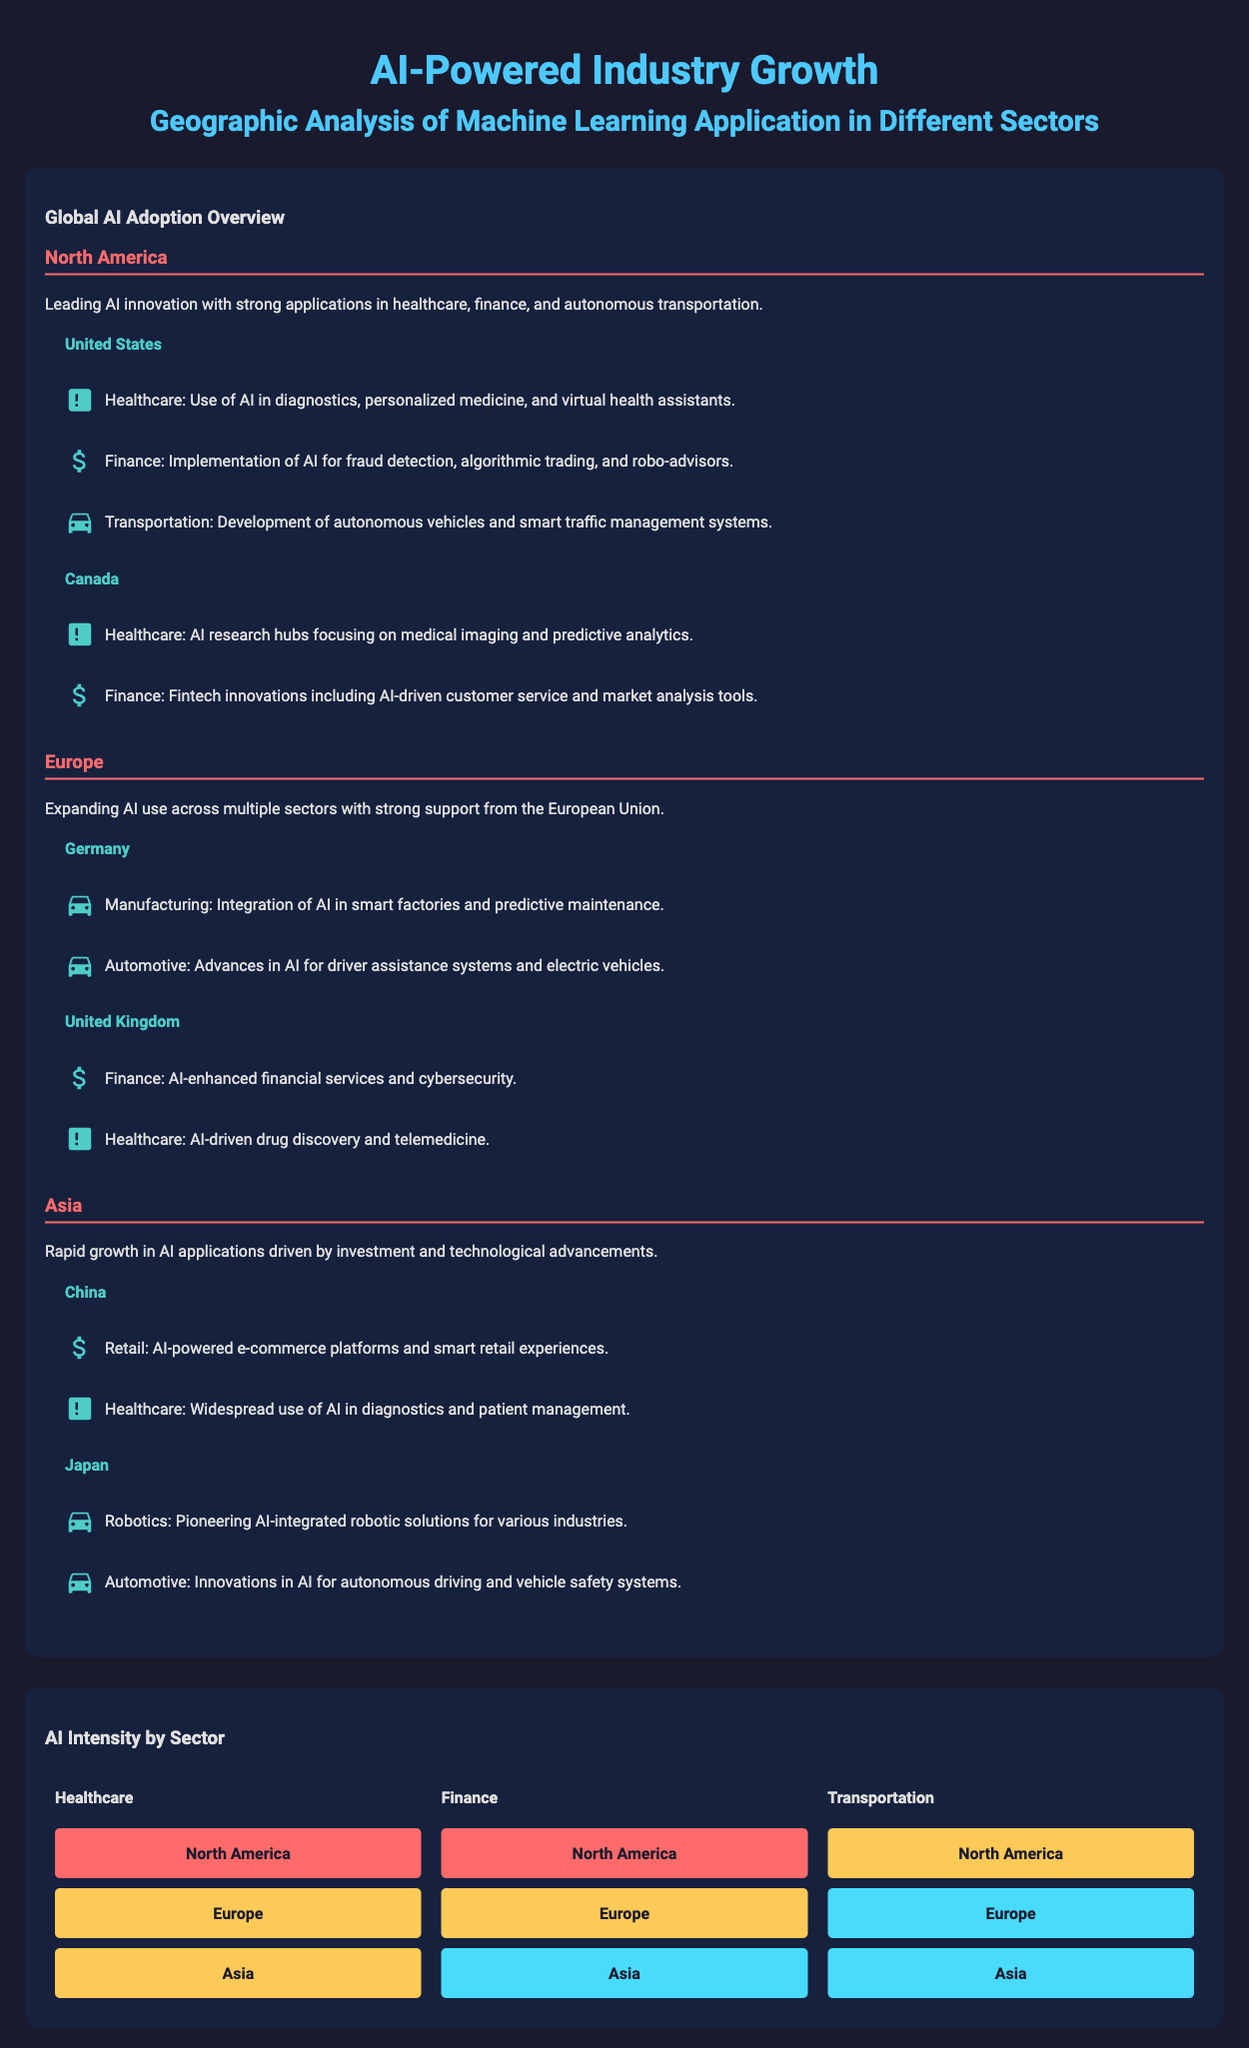What region is leading in AI innovation? North America is described as the leading region for AI innovation within the document.
Answer: North America Which country is mentioned first in the healthcare sector under North America? The document lists the United States first regarding healthcare applications of AI.
Answer: United States How many sectors are listed under the United Kingdom? The United Kingdom has two sectors mentioned in the document: finance and healthcare.
Answer: Two What is the AI intensity level for healthcare in Asia? The document indicates that the AI intensity level for healthcare in Asia is intensity level 4.
Answer: Intensity 4 Which Asian country focuses on robotics according to the infographic? The document mentions Japan as the country pioneering AI-integrated robotic solutions.
Answer: Japan What are the main sectors highlighted in the heatmap section? The infographic emphasizes three sectors in the heatmap: healthcare, finance, and transportation.
Answer: Healthcare, finance, transportation Which region has the highest intensity for finance according to the heatmap? The heatmap shows that North America has the highest intensity for finance applications.
Answer: North America What sector uses AI for drug discovery as per the United Kingdom's description? The document states that the healthcare sector uses AI for drug discovery in the United Kingdom.
Answer: Healthcare In which sector does Germany apply AI for predictive maintenance? The document mentions that Germany integrates AI in the manufacturing sector for predictive maintenance.
Answer: Manufacturing 